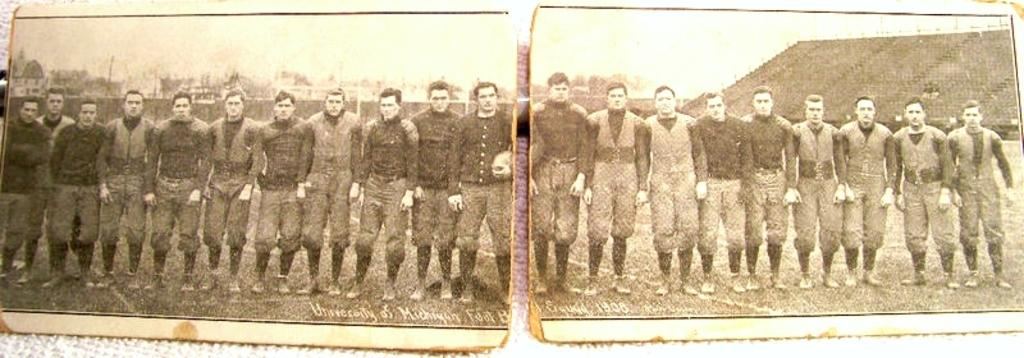How many pictures are in the image? There are two pictures in the image. What is happening in each picture? In each picture, a group of men are standing on the ground. What is the color scheme of the pictures? The pictures are black and white in color. What can be seen in the background of the image? There is a house visible in the background of the image, along with other objects. Can you see the moon in the background of the image? No, the moon is not visible in the background of the image. 